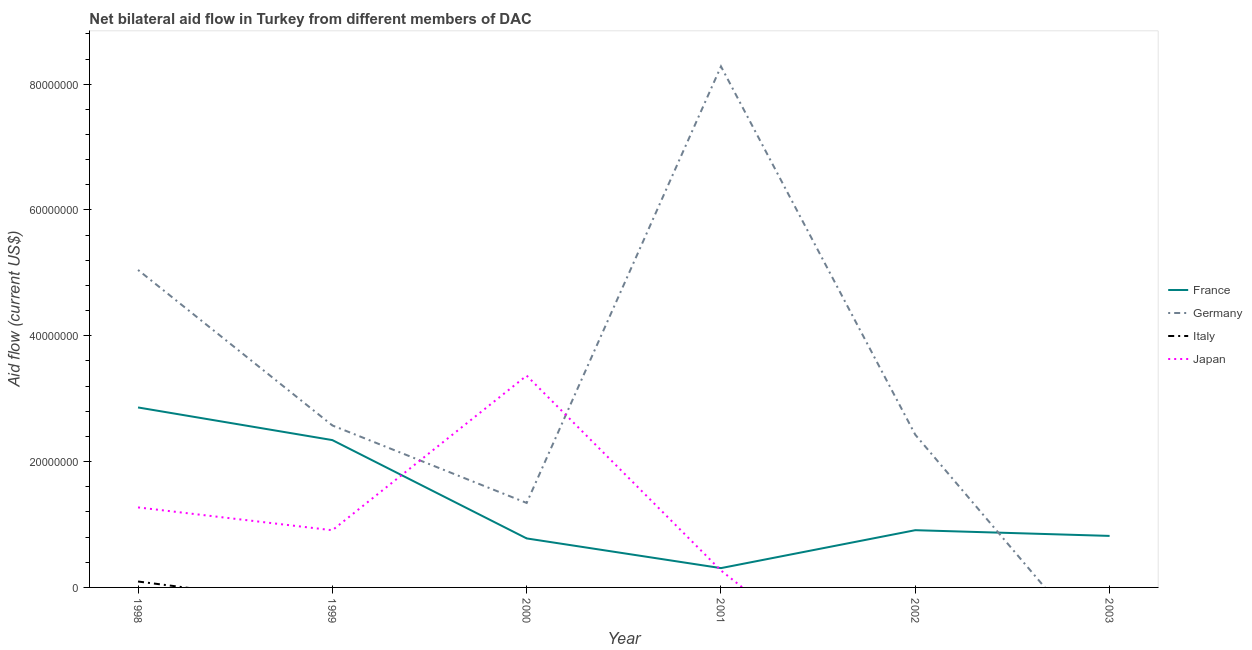What is the amount of aid given by france in 1999?
Offer a terse response. 2.34e+07. Across all years, what is the maximum amount of aid given by germany?
Provide a succinct answer. 8.28e+07. In which year was the amount of aid given by germany maximum?
Make the answer very short. 2001. What is the total amount of aid given by japan in the graph?
Your answer should be compact. 5.82e+07. What is the difference between the amount of aid given by germany in 1999 and that in 2000?
Keep it short and to the point. 1.23e+07. What is the difference between the amount of aid given by germany in 2000 and the amount of aid given by italy in 2001?
Provide a short and direct response. 1.34e+07. What is the average amount of aid given by france per year?
Your answer should be compact. 1.34e+07. In the year 1999, what is the difference between the amount of aid given by france and amount of aid given by germany?
Offer a terse response. -2.33e+06. What is the ratio of the amount of aid given by france in 2001 to that in 2003?
Your answer should be very brief. 0.37. Is the amount of aid given by japan in 1999 less than that in 2001?
Ensure brevity in your answer.  No. Is the difference between the amount of aid given by japan in 1998 and 1999 greater than the difference between the amount of aid given by germany in 1998 and 1999?
Provide a short and direct response. No. What is the difference between the highest and the second highest amount of aid given by france?
Make the answer very short. 5.19e+06. What is the difference between the highest and the lowest amount of aid given by italy?
Your answer should be compact. 9.40e+05. Is it the case that in every year, the sum of the amount of aid given by italy and amount of aid given by france is greater than the sum of amount of aid given by germany and amount of aid given by japan?
Your answer should be compact. No. Is it the case that in every year, the sum of the amount of aid given by france and amount of aid given by germany is greater than the amount of aid given by italy?
Offer a very short reply. Yes. Does the amount of aid given by italy monotonically increase over the years?
Your answer should be compact. No. Is the amount of aid given by italy strictly less than the amount of aid given by japan over the years?
Your response must be concise. No. What is the difference between two consecutive major ticks on the Y-axis?
Make the answer very short. 2.00e+07. Are the values on the major ticks of Y-axis written in scientific E-notation?
Your answer should be compact. No. Does the graph contain any zero values?
Your answer should be compact. Yes. How many legend labels are there?
Your response must be concise. 4. What is the title of the graph?
Offer a very short reply. Net bilateral aid flow in Turkey from different members of DAC. Does "Burnt food" appear as one of the legend labels in the graph?
Provide a short and direct response. No. What is the label or title of the X-axis?
Ensure brevity in your answer.  Year. What is the Aid flow (current US$) of France in 1998?
Keep it short and to the point. 2.86e+07. What is the Aid flow (current US$) of Germany in 1998?
Your answer should be very brief. 5.05e+07. What is the Aid flow (current US$) of Italy in 1998?
Your response must be concise. 9.40e+05. What is the Aid flow (current US$) in Japan in 1998?
Your answer should be compact. 1.27e+07. What is the Aid flow (current US$) in France in 1999?
Give a very brief answer. 2.34e+07. What is the Aid flow (current US$) of Germany in 1999?
Offer a terse response. 2.58e+07. What is the Aid flow (current US$) in Italy in 1999?
Offer a terse response. 0. What is the Aid flow (current US$) in Japan in 1999?
Offer a very short reply. 9.09e+06. What is the Aid flow (current US$) of France in 2000?
Make the answer very short. 7.79e+06. What is the Aid flow (current US$) in Germany in 2000?
Make the answer very short. 1.34e+07. What is the Aid flow (current US$) in Japan in 2000?
Make the answer very short. 3.37e+07. What is the Aid flow (current US$) in France in 2001?
Give a very brief answer. 3.07e+06. What is the Aid flow (current US$) of Germany in 2001?
Provide a succinct answer. 8.28e+07. What is the Aid flow (current US$) in Italy in 2001?
Give a very brief answer. 0. What is the Aid flow (current US$) of Japan in 2001?
Give a very brief answer. 2.69e+06. What is the Aid flow (current US$) in France in 2002?
Give a very brief answer. 9.10e+06. What is the Aid flow (current US$) of Germany in 2002?
Make the answer very short. 2.43e+07. What is the Aid flow (current US$) in Italy in 2002?
Ensure brevity in your answer.  0. What is the Aid flow (current US$) of France in 2003?
Provide a short and direct response. 8.19e+06. What is the Aid flow (current US$) in Japan in 2003?
Provide a succinct answer. 0. Across all years, what is the maximum Aid flow (current US$) of France?
Your answer should be very brief. 2.86e+07. Across all years, what is the maximum Aid flow (current US$) of Germany?
Provide a short and direct response. 8.28e+07. Across all years, what is the maximum Aid flow (current US$) in Italy?
Offer a very short reply. 9.40e+05. Across all years, what is the maximum Aid flow (current US$) of Japan?
Keep it short and to the point. 3.37e+07. Across all years, what is the minimum Aid flow (current US$) in France?
Your answer should be very brief. 3.07e+06. Across all years, what is the minimum Aid flow (current US$) in Italy?
Ensure brevity in your answer.  0. What is the total Aid flow (current US$) of France in the graph?
Provide a short and direct response. 8.02e+07. What is the total Aid flow (current US$) in Germany in the graph?
Provide a succinct answer. 1.97e+08. What is the total Aid flow (current US$) of Italy in the graph?
Offer a very short reply. 9.40e+05. What is the total Aid flow (current US$) of Japan in the graph?
Ensure brevity in your answer.  5.82e+07. What is the difference between the Aid flow (current US$) in France in 1998 and that in 1999?
Your answer should be very brief. 5.19e+06. What is the difference between the Aid flow (current US$) of Germany in 1998 and that in 1999?
Provide a succinct answer. 2.47e+07. What is the difference between the Aid flow (current US$) of Japan in 1998 and that in 1999?
Offer a terse response. 3.63e+06. What is the difference between the Aid flow (current US$) in France in 1998 and that in 2000?
Provide a short and direct response. 2.08e+07. What is the difference between the Aid flow (current US$) in Germany in 1998 and that in 2000?
Your answer should be very brief. 3.70e+07. What is the difference between the Aid flow (current US$) of Japan in 1998 and that in 2000?
Give a very brief answer. -2.10e+07. What is the difference between the Aid flow (current US$) in France in 1998 and that in 2001?
Provide a succinct answer. 2.55e+07. What is the difference between the Aid flow (current US$) in Germany in 1998 and that in 2001?
Offer a terse response. -3.24e+07. What is the difference between the Aid flow (current US$) in Japan in 1998 and that in 2001?
Offer a very short reply. 1.00e+07. What is the difference between the Aid flow (current US$) in France in 1998 and that in 2002?
Give a very brief answer. 1.95e+07. What is the difference between the Aid flow (current US$) of Germany in 1998 and that in 2002?
Give a very brief answer. 2.62e+07. What is the difference between the Aid flow (current US$) of France in 1998 and that in 2003?
Offer a terse response. 2.04e+07. What is the difference between the Aid flow (current US$) in France in 1999 and that in 2000?
Give a very brief answer. 1.56e+07. What is the difference between the Aid flow (current US$) of Germany in 1999 and that in 2000?
Offer a very short reply. 1.23e+07. What is the difference between the Aid flow (current US$) of Japan in 1999 and that in 2000?
Make the answer very short. -2.46e+07. What is the difference between the Aid flow (current US$) in France in 1999 and that in 2001?
Keep it short and to the point. 2.04e+07. What is the difference between the Aid flow (current US$) of Germany in 1999 and that in 2001?
Provide a succinct answer. -5.71e+07. What is the difference between the Aid flow (current US$) of Japan in 1999 and that in 2001?
Your answer should be very brief. 6.40e+06. What is the difference between the Aid flow (current US$) in France in 1999 and that in 2002?
Give a very brief answer. 1.43e+07. What is the difference between the Aid flow (current US$) in Germany in 1999 and that in 2002?
Your answer should be compact. 1.48e+06. What is the difference between the Aid flow (current US$) in France in 1999 and that in 2003?
Your answer should be very brief. 1.52e+07. What is the difference between the Aid flow (current US$) of France in 2000 and that in 2001?
Give a very brief answer. 4.72e+06. What is the difference between the Aid flow (current US$) of Germany in 2000 and that in 2001?
Provide a succinct answer. -6.94e+07. What is the difference between the Aid flow (current US$) in Japan in 2000 and that in 2001?
Make the answer very short. 3.10e+07. What is the difference between the Aid flow (current US$) in France in 2000 and that in 2002?
Ensure brevity in your answer.  -1.31e+06. What is the difference between the Aid flow (current US$) in Germany in 2000 and that in 2002?
Keep it short and to the point. -1.08e+07. What is the difference between the Aid flow (current US$) in France in 2000 and that in 2003?
Your answer should be very brief. -4.00e+05. What is the difference between the Aid flow (current US$) of France in 2001 and that in 2002?
Your response must be concise. -6.03e+06. What is the difference between the Aid flow (current US$) in Germany in 2001 and that in 2002?
Your answer should be compact. 5.86e+07. What is the difference between the Aid flow (current US$) of France in 2001 and that in 2003?
Your response must be concise. -5.12e+06. What is the difference between the Aid flow (current US$) in France in 2002 and that in 2003?
Your answer should be compact. 9.10e+05. What is the difference between the Aid flow (current US$) of France in 1998 and the Aid flow (current US$) of Germany in 1999?
Your answer should be very brief. 2.86e+06. What is the difference between the Aid flow (current US$) in France in 1998 and the Aid flow (current US$) in Japan in 1999?
Keep it short and to the point. 1.95e+07. What is the difference between the Aid flow (current US$) of Germany in 1998 and the Aid flow (current US$) of Japan in 1999?
Your answer should be compact. 4.14e+07. What is the difference between the Aid flow (current US$) of Italy in 1998 and the Aid flow (current US$) of Japan in 1999?
Your response must be concise. -8.15e+06. What is the difference between the Aid flow (current US$) of France in 1998 and the Aid flow (current US$) of Germany in 2000?
Your answer should be very brief. 1.52e+07. What is the difference between the Aid flow (current US$) of France in 1998 and the Aid flow (current US$) of Japan in 2000?
Keep it short and to the point. -5.06e+06. What is the difference between the Aid flow (current US$) of Germany in 1998 and the Aid flow (current US$) of Japan in 2000?
Your answer should be very brief. 1.68e+07. What is the difference between the Aid flow (current US$) of Italy in 1998 and the Aid flow (current US$) of Japan in 2000?
Offer a very short reply. -3.27e+07. What is the difference between the Aid flow (current US$) in France in 1998 and the Aid flow (current US$) in Germany in 2001?
Offer a terse response. -5.42e+07. What is the difference between the Aid flow (current US$) in France in 1998 and the Aid flow (current US$) in Japan in 2001?
Make the answer very short. 2.59e+07. What is the difference between the Aid flow (current US$) of Germany in 1998 and the Aid flow (current US$) of Japan in 2001?
Keep it short and to the point. 4.78e+07. What is the difference between the Aid flow (current US$) in Italy in 1998 and the Aid flow (current US$) in Japan in 2001?
Offer a terse response. -1.75e+06. What is the difference between the Aid flow (current US$) in France in 1998 and the Aid flow (current US$) in Germany in 2002?
Offer a terse response. 4.34e+06. What is the difference between the Aid flow (current US$) of France in 1999 and the Aid flow (current US$) of Germany in 2000?
Offer a very short reply. 9.99e+06. What is the difference between the Aid flow (current US$) in France in 1999 and the Aid flow (current US$) in Japan in 2000?
Provide a succinct answer. -1.02e+07. What is the difference between the Aid flow (current US$) in Germany in 1999 and the Aid flow (current US$) in Japan in 2000?
Your answer should be compact. -7.92e+06. What is the difference between the Aid flow (current US$) in France in 1999 and the Aid flow (current US$) in Germany in 2001?
Your response must be concise. -5.94e+07. What is the difference between the Aid flow (current US$) of France in 1999 and the Aid flow (current US$) of Japan in 2001?
Give a very brief answer. 2.07e+07. What is the difference between the Aid flow (current US$) of Germany in 1999 and the Aid flow (current US$) of Japan in 2001?
Your response must be concise. 2.31e+07. What is the difference between the Aid flow (current US$) in France in 1999 and the Aid flow (current US$) in Germany in 2002?
Ensure brevity in your answer.  -8.50e+05. What is the difference between the Aid flow (current US$) in France in 2000 and the Aid flow (current US$) in Germany in 2001?
Offer a terse response. -7.50e+07. What is the difference between the Aid flow (current US$) of France in 2000 and the Aid flow (current US$) of Japan in 2001?
Offer a terse response. 5.10e+06. What is the difference between the Aid flow (current US$) of Germany in 2000 and the Aid flow (current US$) of Japan in 2001?
Your answer should be very brief. 1.07e+07. What is the difference between the Aid flow (current US$) in France in 2000 and the Aid flow (current US$) in Germany in 2002?
Ensure brevity in your answer.  -1.65e+07. What is the difference between the Aid flow (current US$) in France in 2001 and the Aid flow (current US$) in Germany in 2002?
Offer a very short reply. -2.12e+07. What is the average Aid flow (current US$) in France per year?
Your response must be concise. 1.34e+07. What is the average Aid flow (current US$) in Germany per year?
Ensure brevity in your answer.  3.28e+07. What is the average Aid flow (current US$) in Italy per year?
Keep it short and to the point. 1.57e+05. What is the average Aid flow (current US$) in Japan per year?
Offer a terse response. 9.70e+06. In the year 1998, what is the difference between the Aid flow (current US$) in France and Aid flow (current US$) in Germany?
Offer a very short reply. -2.19e+07. In the year 1998, what is the difference between the Aid flow (current US$) of France and Aid flow (current US$) of Italy?
Keep it short and to the point. 2.77e+07. In the year 1998, what is the difference between the Aid flow (current US$) in France and Aid flow (current US$) in Japan?
Provide a short and direct response. 1.59e+07. In the year 1998, what is the difference between the Aid flow (current US$) in Germany and Aid flow (current US$) in Italy?
Provide a short and direct response. 4.95e+07. In the year 1998, what is the difference between the Aid flow (current US$) in Germany and Aid flow (current US$) in Japan?
Offer a terse response. 3.78e+07. In the year 1998, what is the difference between the Aid flow (current US$) of Italy and Aid flow (current US$) of Japan?
Make the answer very short. -1.18e+07. In the year 1999, what is the difference between the Aid flow (current US$) of France and Aid flow (current US$) of Germany?
Offer a terse response. -2.33e+06. In the year 1999, what is the difference between the Aid flow (current US$) of France and Aid flow (current US$) of Japan?
Your answer should be compact. 1.43e+07. In the year 1999, what is the difference between the Aid flow (current US$) in Germany and Aid flow (current US$) in Japan?
Offer a terse response. 1.67e+07. In the year 2000, what is the difference between the Aid flow (current US$) in France and Aid flow (current US$) in Germany?
Keep it short and to the point. -5.64e+06. In the year 2000, what is the difference between the Aid flow (current US$) in France and Aid flow (current US$) in Japan?
Your answer should be very brief. -2.59e+07. In the year 2000, what is the difference between the Aid flow (current US$) in Germany and Aid flow (current US$) in Japan?
Your response must be concise. -2.02e+07. In the year 2001, what is the difference between the Aid flow (current US$) of France and Aid flow (current US$) of Germany?
Your response must be concise. -7.98e+07. In the year 2001, what is the difference between the Aid flow (current US$) of Germany and Aid flow (current US$) of Japan?
Offer a very short reply. 8.01e+07. In the year 2002, what is the difference between the Aid flow (current US$) of France and Aid flow (current US$) of Germany?
Keep it short and to the point. -1.52e+07. What is the ratio of the Aid flow (current US$) in France in 1998 to that in 1999?
Keep it short and to the point. 1.22. What is the ratio of the Aid flow (current US$) of Germany in 1998 to that in 1999?
Provide a short and direct response. 1.96. What is the ratio of the Aid flow (current US$) in Japan in 1998 to that in 1999?
Keep it short and to the point. 1.4. What is the ratio of the Aid flow (current US$) of France in 1998 to that in 2000?
Give a very brief answer. 3.67. What is the ratio of the Aid flow (current US$) in Germany in 1998 to that in 2000?
Give a very brief answer. 3.76. What is the ratio of the Aid flow (current US$) of Japan in 1998 to that in 2000?
Your answer should be very brief. 0.38. What is the ratio of the Aid flow (current US$) of France in 1998 to that in 2001?
Provide a short and direct response. 9.32. What is the ratio of the Aid flow (current US$) of Germany in 1998 to that in 2001?
Provide a succinct answer. 0.61. What is the ratio of the Aid flow (current US$) in Japan in 1998 to that in 2001?
Offer a terse response. 4.73. What is the ratio of the Aid flow (current US$) in France in 1998 to that in 2002?
Offer a terse response. 3.14. What is the ratio of the Aid flow (current US$) of Germany in 1998 to that in 2002?
Your response must be concise. 2.08. What is the ratio of the Aid flow (current US$) of France in 1998 to that in 2003?
Offer a terse response. 3.49. What is the ratio of the Aid flow (current US$) in France in 1999 to that in 2000?
Your answer should be very brief. 3.01. What is the ratio of the Aid flow (current US$) in Germany in 1999 to that in 2000?
Give a very brief answer. 1.92. What is the ratio of the Aid flow (current US$) in Japan in 1999 to that in 2000?
Make the answer very short. 0.27. What is the ratio of the Aid flow (current US$) of France in 1999 to that in 2001?
Your answer should be very brief. 7.63. What is the ratio of the Aid flow (current US$) of Germany in 1999 to that in 2001?
Keep it short and to the point. 0.31. What is the ratio of the Aid flow (current US$) of Japan in 1999 to that in 2001?
Your response must be concise. 3.38. What is the ratio of the Aid flow (current US$) of France in 1999 to that in 2002?
Provide a succinct answer. 2.57. What is the ratio of the Aid flow (current US$) of Germany in 1999 to that in 2002?
Your response must be concise. 1.06. What is the ratio of the Aid flow (current US$) of France in 1999 to that in 2003?
Provide a succinct answer. 2.86. What is the ratio of the Aid flow (current US$) of France in 2000 to that in 2001?
Offer a very short reply. 2.54. What is the ratio of the Aid flow (current US$) in Germany in 2000 to that in 2001?
Keep it short and to the point. 0.16. What is the ratio of the Aid flow (current US$) in Japan in 2000 to that in 2001?
Provide a short and direct response. 12.52. What is the ratio of the Aid flow (current US$) of France in 2000 to that in 2002?
Your answer should be compact. 0.86. What is the ratio of the Aid flow (current US$) in Germany in 2000 to that in 2002?
Your answer should be very brief. 0.55. What is the ratio of the Aid flow (current US$) in France in 2000 to that in 2003?
Give a very brief answer. 0.95. What is the ratio of the Aid flow (current US$) in France in 2001 to that in 2002?
Your answer should be very brief. 0.34. What is the ratio of the Aid flow (current US$) in Germany in 2001 to that in 2002?
Keep it short and to the point. 3.41. What is the ratio of the Aid flow (current US$) in France in 2001 to that in 2003?
Provide a succinct answer. 0.37. What is the difference between the highest and the second highest Aid flow (current US$) in France?
Keep it short and to the point. 5.19e+06. What is the difference between the highest and the second highest Aid flow (current US$) of Germany?
Your response must be concise. 3.24e+07. What is the difference between the highest and the second highest Aid flow (current US$) of Japan?
Your response must be concise. 2.10e+07. What is the difference between the highest and the lowest Aid flow (current US$) of France?
Make the answer very short. 2.55e+07. What is the difference between the highest and the lowest Aid flow (current US$) of Germany?
Keep it short and to the point. 8.28e+07. What is the difference between the highest and the lowest Aid flow (current US$) of Italy?
Ensure brevity in your answer.  9.40e+05. What is the difference between the highest and the lowest Aid flow (current US$) in Japan?
Offer a terse response. 3.37e+07. 